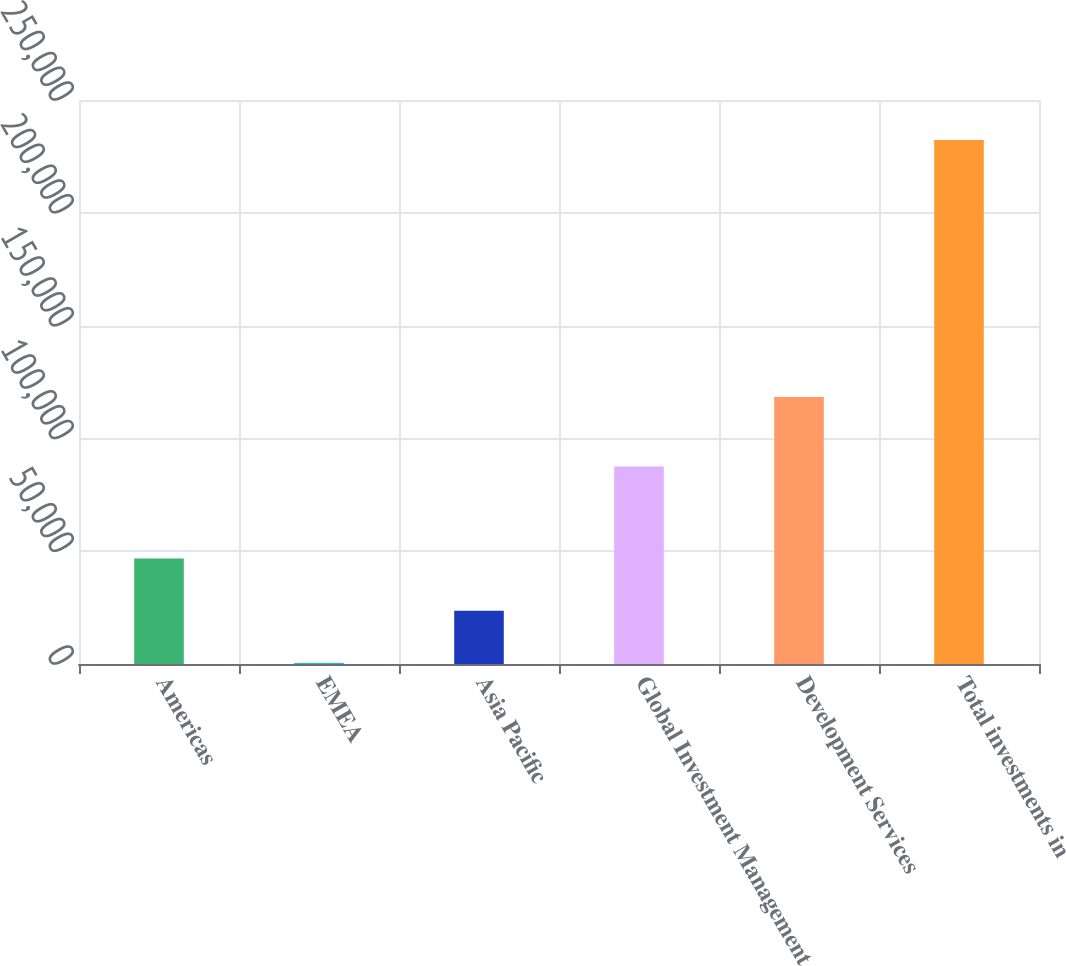Convert chart to OTSL. <chart><loc_0><loc_0><loc_500><loc_500><bar_chart><fcel>Americas<fcel>EMEA<fcel>Asia Pacific<fcel>Global Investment Management<fcel>Development Services<fcel>Total investments in<nl><fcel>46758<fcel>388<fcel>23573<fcel>87501<fcel>118345<fcel>232238<nl></chart> 